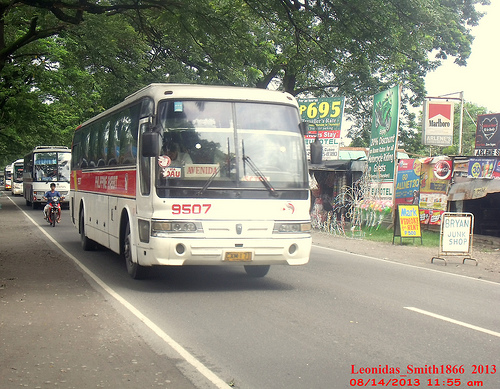Please provide the bounding box coordinate of the region this sentence describes: A big green tree over the bus. The bounding box coordinate for the big green tree over the bus is [0.05, 0.14, 0.73, 0.28]. 